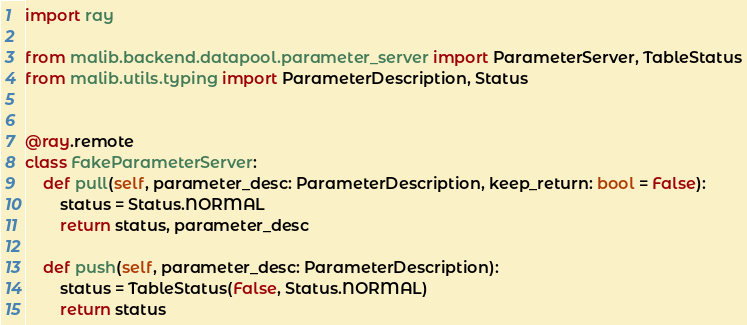<code> <loc_0><loc_0><loc_500><loc_500><_Python_>import ray

from malib.backend.datapool.parameter_server import ParameterServer, TableStatus
from malib.utils.typing import ParameterDescription, Status


@ray.remote
class FakeParameterServer:
    def pull(self, parameter_desc: ParameterDescription, keep_return: bool = False):
        status = Status.NORMAL
        return status, parameter_desc

    def push(self, parameter_desc: ParameterDescription):
        status = TableStatus(False, Status.NORMAL)
        return status
</code> 